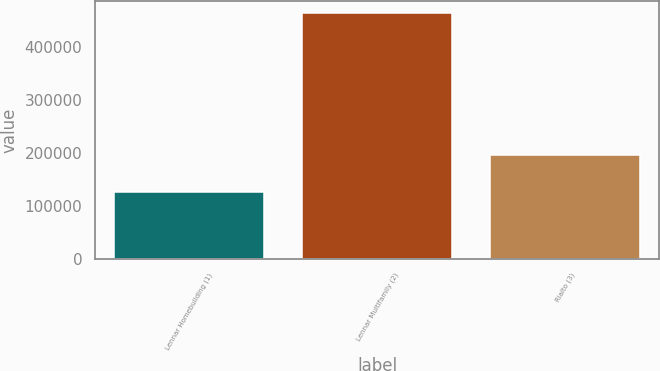Convert chart to OTSL. <chart><loc_0><loc_0><loc_500><loc_500><bar_chart><fcel>Lennar Homebuilding (1)<fcel>Lennar Multifamily (2)<fcel>Rialto (3)<nl><fcel>127009<fcel>463534<fcel>196956<nl></chart> 